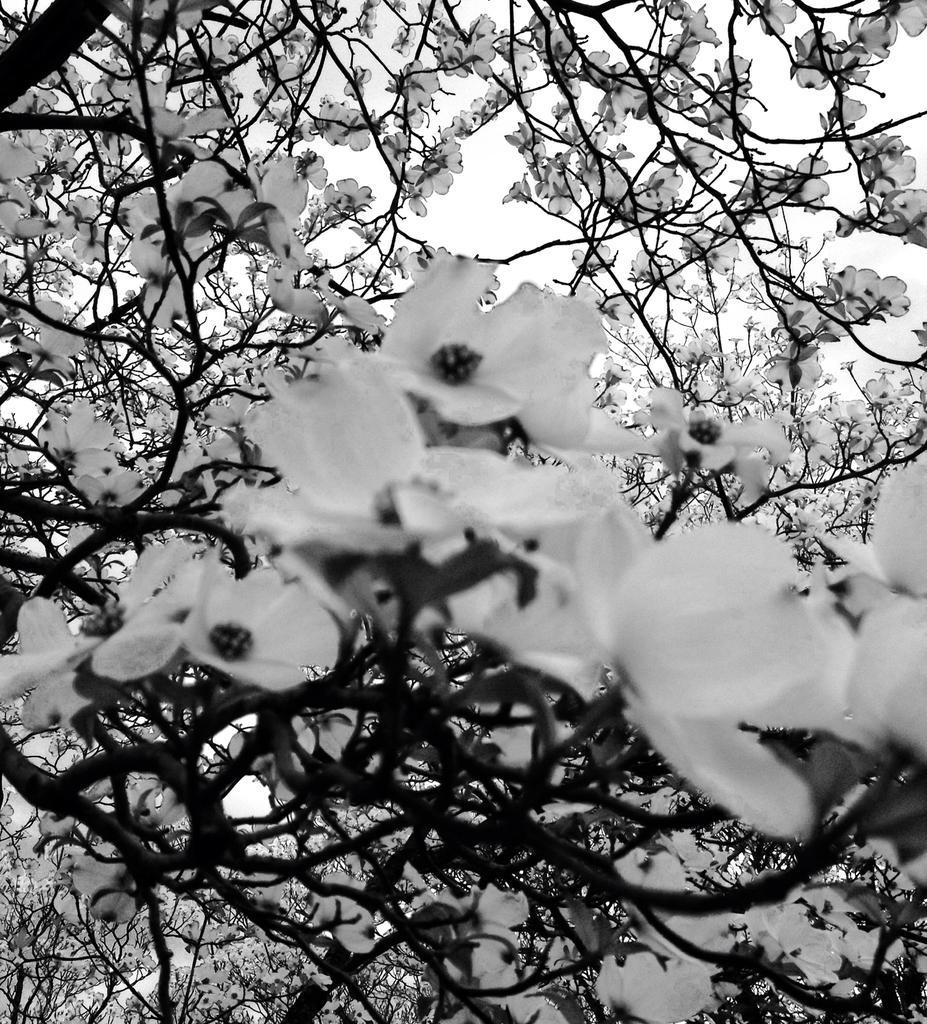How would you summarize this image in a sentence or two? In the image there are flower plants and this is a black and white picture. 